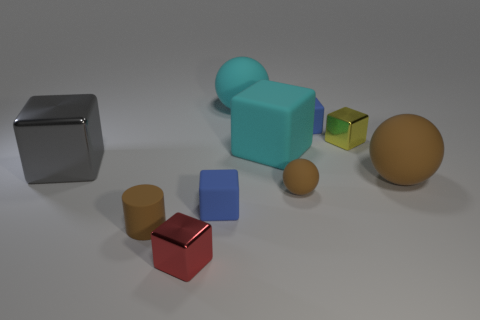What can the arrangement of these objects tell us about the context in which this image was taken? The orderly scattering of geometric shapes and the soft shadowing give the impression of a setup for a 3D modeling or graphic design presentation. These objects are often used for testing rendering techniques or demonstrating spatial relationships in visual arts. Could these objects be part of a physical simulation? Exactly, these types of objects are typically used in physics simulations within computer graphics software to showcase how different shapes react under certain conditions like lighting or collisions. 